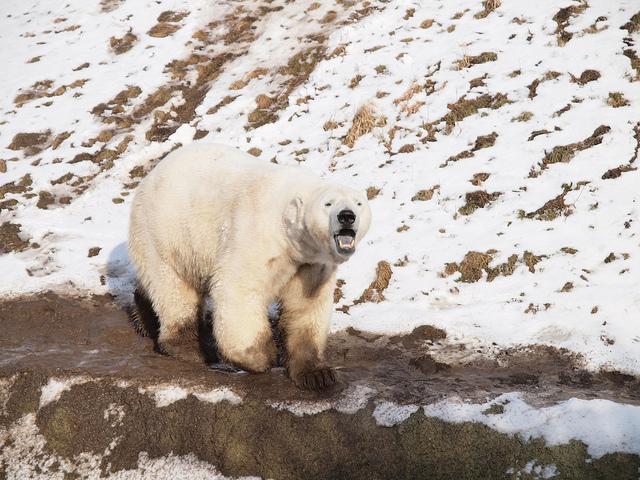How many animals are pictured here?
Give a very brief answer. 1. How many motorcycles have two helmets?
Give a very brief answer. 0. 